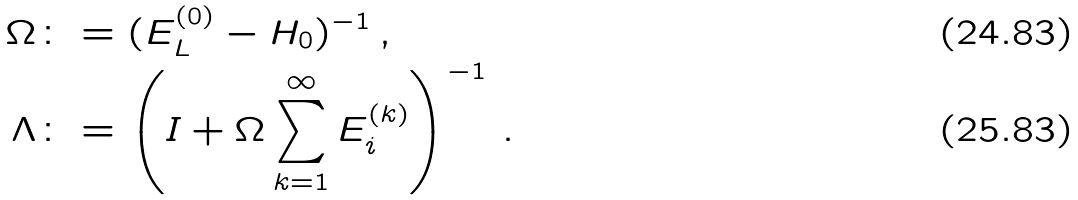Convert formula to latex. <formula><loc_0><loc_0><loc_500><loc_500>\Omega & \colon = ( E _ { L } ^ { ( 0 ) } - H _ { 0 } ) ^ { - 1 } \, , \\ \Lambda & \colon = \left ( I + \Omega \sum _ { k = 1 } ^ { \infty } E _ { i } ^ { ( k ) } \right ) ^ { - 1 } \, .</formula> 